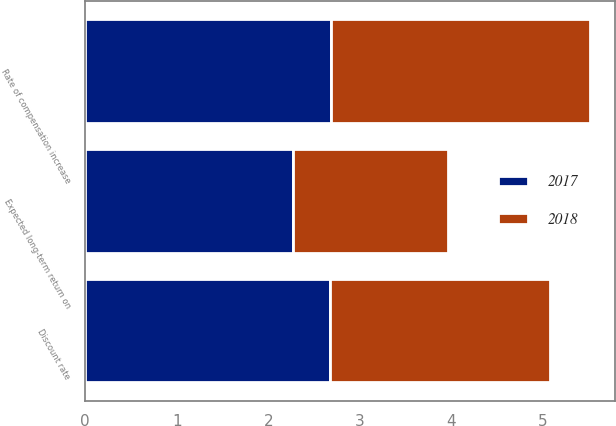Convert chart. <chart><loc_0><loc_0><loc_500><loc_500><stacked_bar_chart><ecel><fcel>Discount rate<fcel>Rate of compensation increase<fcel>Expected long-term return on<nl><fcel>2017<fcel>2.67<fcel>2.68<fcel>2.27<nl><fcel>2018<fcel>2.41<fcel>2.83<fcel>1.69<nl></chart> 